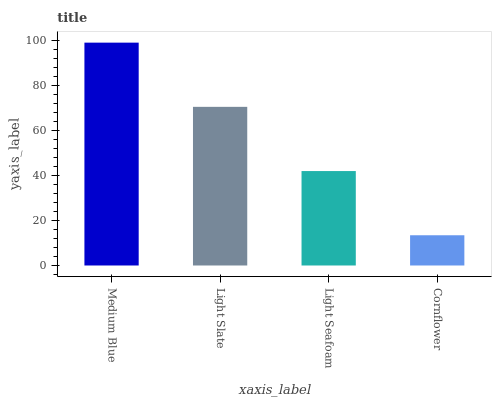Is Cornflower the minimum?
Answer yes or no. Yes. Is Medium Blue the maximum?
Answer yes or no. Yes. Is Light Slate the minimum?
Answer yes or no. No. Is Light Slate the maximum?
Answer yes or no. No. Is Medium Blue greater than Light Slate?
Answer yes or no. Yes. Is Light Slate less than Medium Blue?
Answer yes or no. Yes. Is Light Slate greater than Medium Blue?
Answer yes or no. No. Is Medium Blue less than Light Slate?
Answer yes or no. No. Is Light Slate the high median?
Answer yes or no. Yes. Is Light Seafoam the low median?
Answer yes or no. Yes. Is Cornflower the high median?
Answer yes or no. No. Is Medium Blue the low median?
Answer yes or no. No. 